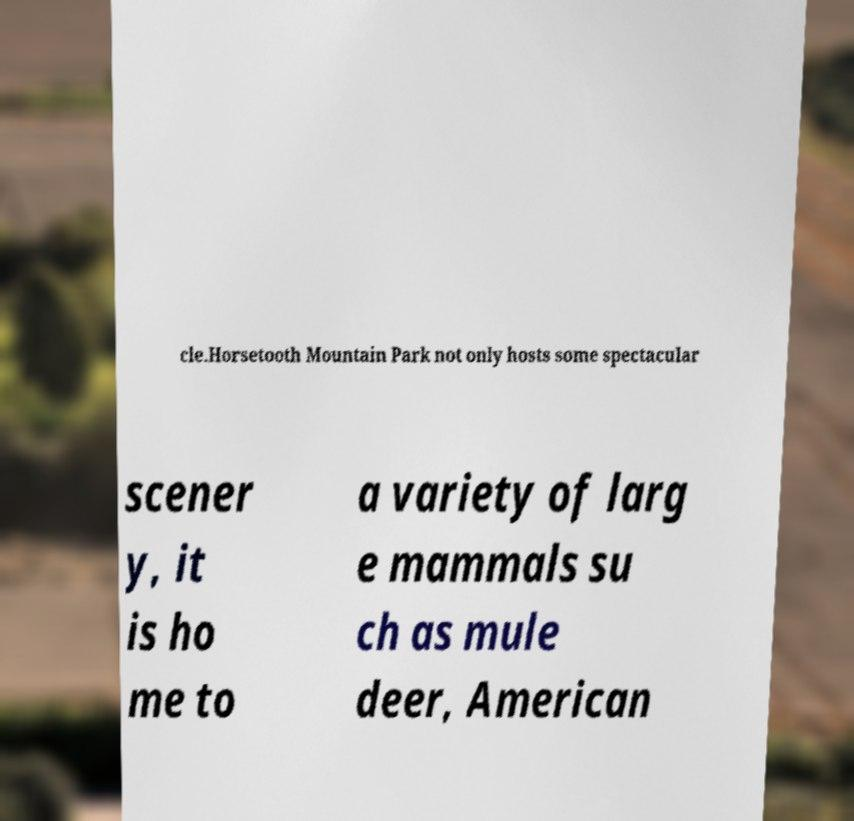Could you extract and type out the text from this image? cle.Horsetooth Mountain Park not only hosts some spectacular scener y, it is ho me to a variety of larg e mammals su ch as mule deer, American 